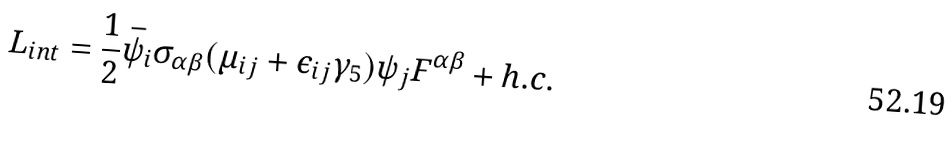Convert formula to latex. <formula><loc_0><loc_0><loc_500><loc_500>L _ { i n t } = \frac { 1 } { 2 } { \bar { \psi } } _ { i } \sigma _ { \alpha \beta } ( \mu _ { i j } + \epsilon _ { i j } \gamma _ { 5 } ) \psi _ { j } F ^ { \alpha \beta } + h . c .</formula> 